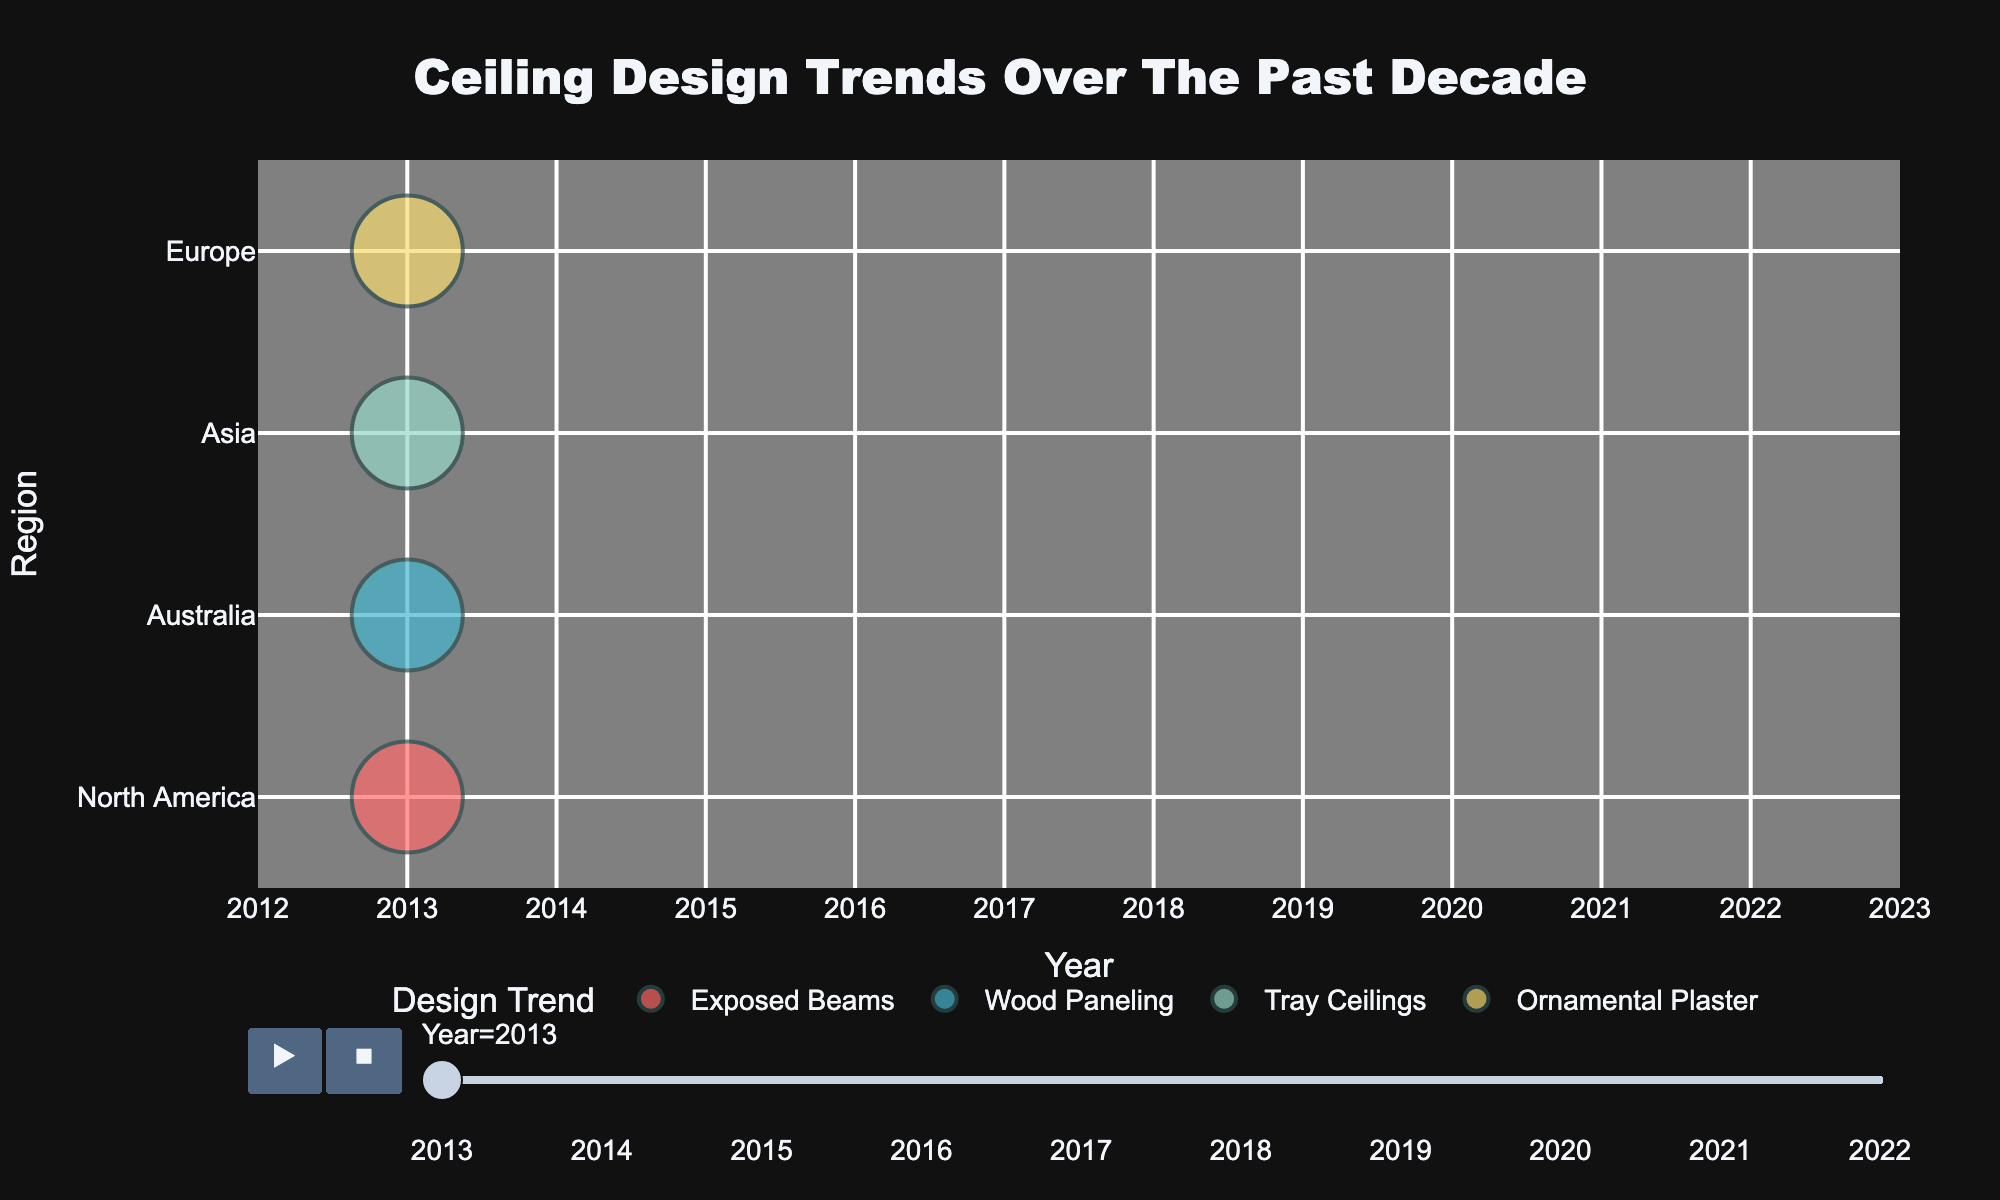What is the title of the figure? The title of the figure is displayed prominently at the top. It reads, "Ceiling Design Trends Over The Past Decade".
Answer: Ceiling Design Trends Over The Past Decade Which design trend has the largest bubble in 2022 in North America? By looking at the bubbles for the different design trends in North America for the year 2022, the Geometric Patterns trend has the largest bubble.
Answer: Geometric Patterns How many regions are represented in the figure? The y-axis lists four distinct regions: North America, Europe, Asia, and Australia.
Answer: 4 What is the smallest bubble size and its corresponding design trend in Europe in 2017? Observing the bubbles under the Europe region for the year 2017, the smallest bubble is for the Geometric Patterns trend.
Answer: Geometric Patterns Which year had the highest occurrences of Exposed Beams across all regions? Comparing the bubbles marked as Exposed Beams across all years and regions, the year with the highest number of occurrences of Exposed Beams is 2021, noticeable due to the larger and more frequent appearance of Exposed Beams bubbles.
Answer: 2021 Which region showed a consistent increase in the popularity of Geometric Patterns trend over the years? Observing the bubbles representing Geometric Patterns, it consistently increases in Asia from 2014 through 2021.
Answer: Asia In which year does North America have the highest bubble size for the Wood Paneling design? By observing the bubbles representing Wood Paneling in North America, the year with the highest bubble size is 2018.
Answer: 2018 How does the transparency of bubbles change with the popularity of design trends in North America in 2022? Referring to North American bubbles in 2022 and their transparency, the trend with the largest bubble size, Geometric Patterns, has a transparency of 0.4, while the smallest bubble size, Exposed Beams, has a transparency of 0.2, indicating a higher popularity with less transparency.
Answer: transparency decreases with popularity Which region has the largest bubble for Ornamental Plaster trend throughout the decade? Comparing the bubble sizes of Ornamental Plaster across all regions and years, Europe in 2019 has the largest bubble.
Answer: Europe What's the overall trend for Tray Ceilings in Asia over the examined period? Analyzing the bubbles for Tray Ceilings in Asia from 2013 to 2022, the bubble size peaks in 2016 and 2020, indicating varying popularity but not consistently increasing or decreasing overall.
Answer: varying popularity 